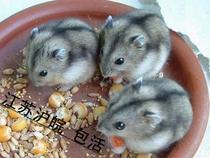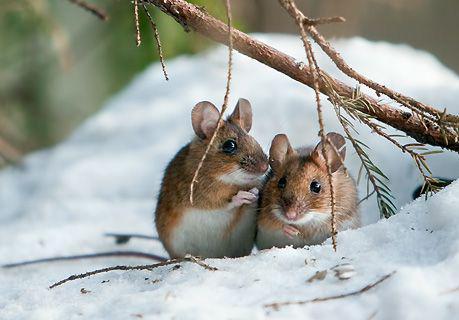The first image is the image on the left, the second image is the image on the right. For the images shown, is this caption "There are two rodents in the image on the right." true? Answer yes or no. Yes. 